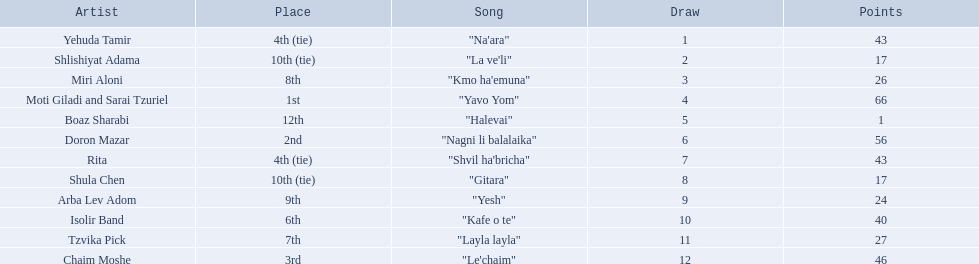Who are all of the artists? Yehuda Tamir, Shlishiyat Adama, Miri Aloni, Moti Giladi and Sarai Tzuriel, Boaz Sharabi, Doron Mazar, Rita, Shula Chen, Arba Lev Adom, Isolir Band, Tzvika Pick, Chaim Moshe. How many points did each score? 43, 17, 26, 66, 1, 56, 43, 17, 24, 40, 27, 46. And which artist had the least amount of points? Boaz Sharabi. 